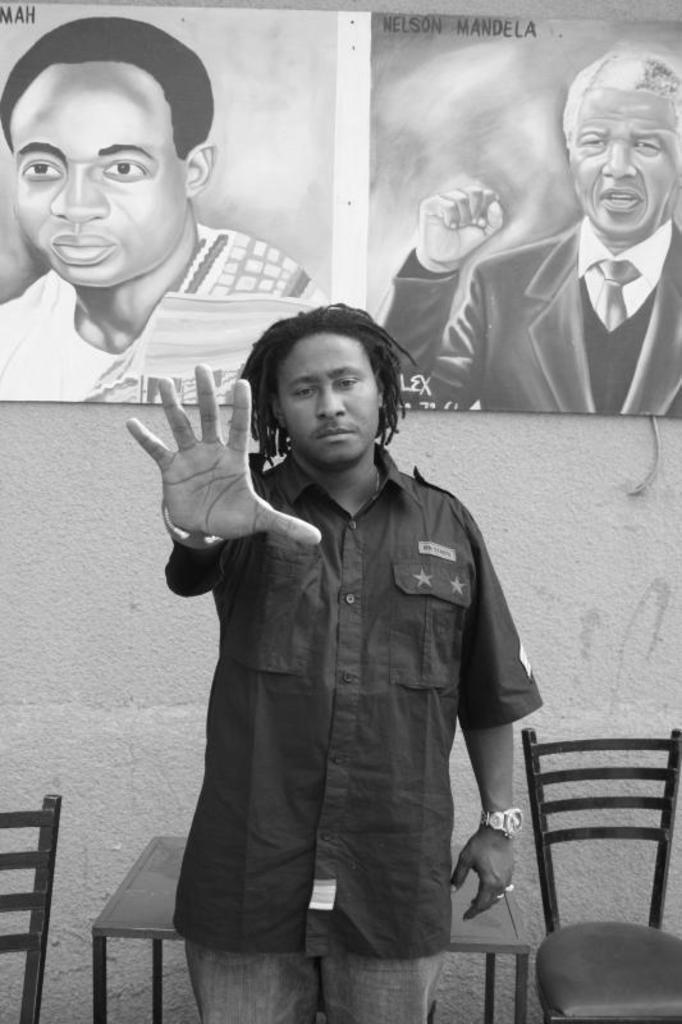How would you summarize this image in a sentence or two? This is of a black and white image. There is a man standing. Behind the man I can see a table and two chairs at the corners of the image. At background I can see a poster which is attached to the wall. 